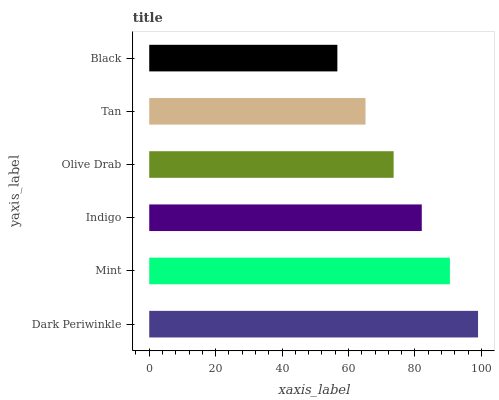Is Black the minimum?
Answer yes or no. Yes. Is Dark Periwinkle the maximum?
Answer yes or no. Yes. Is Mint the minimum?
Answer yes or no. No. Is Mint the maximum?
Answer yes or no. No. Is Dark Periwinkle greater than Mint?
Answer yes or no. Yes. Is Mint less than Dark Periwinkle?
Answer yes or no. Yes. Is Mint greater than Dark Periwinkle?
Answer yes or no. No. Is Dark Periwinkle less than Mint?
Answer yes or no. No. Is Indigo the high median?
Answer yes or no. Yes. Is Olive Drab the low median?
Answer yes or no. Yes. Is Mint the high median?
Answer yes or no. No. Is Tan the low median?
Answer yes or no. No. 